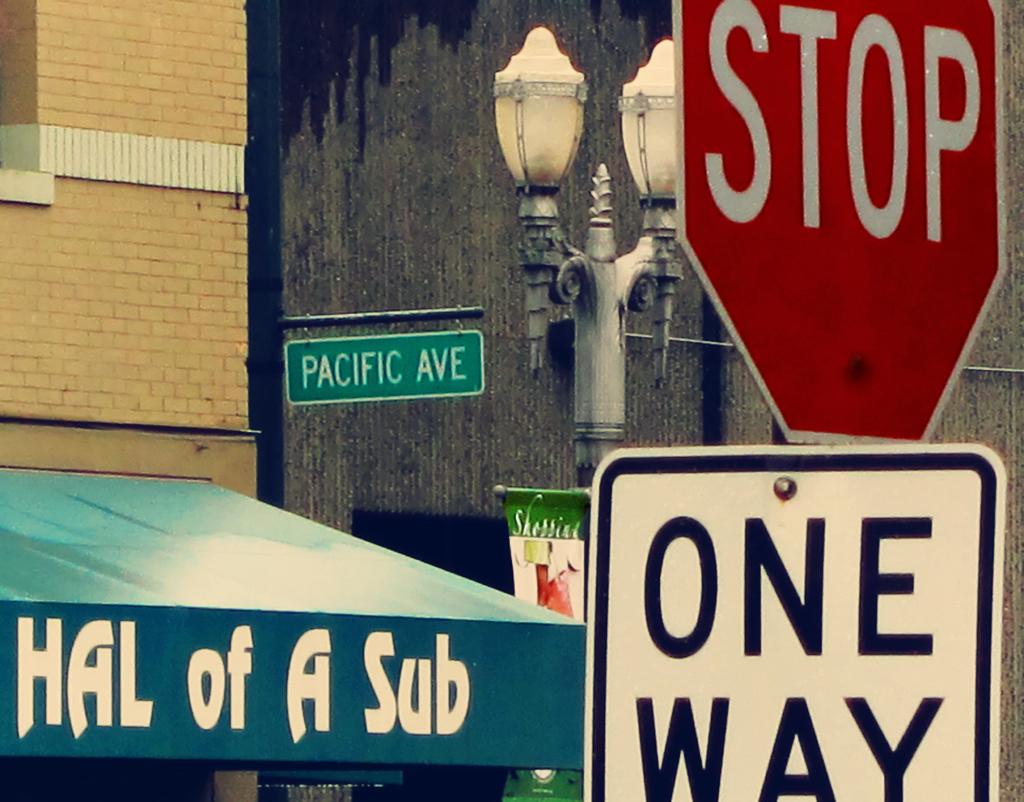What street is shown in the picture?
Provide a short and direct response. Pacific ave. What's the name of the restaurant?
Keep it short and to the point. Hal of a sub. 